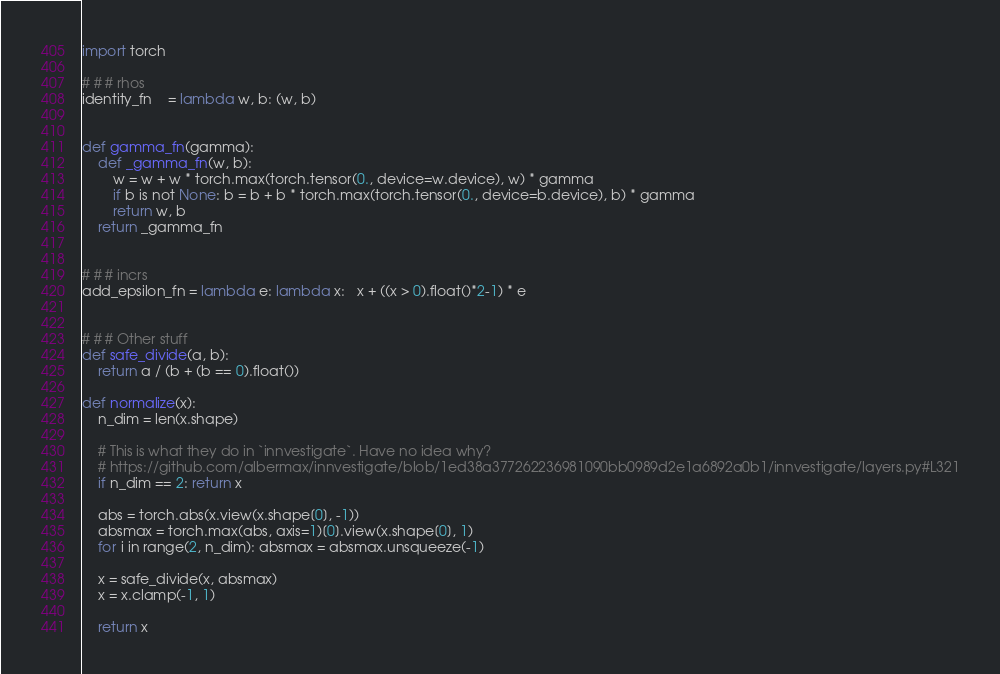<code> <loc_0><loc_0><loc_500><loc_500><_Python_>import torch

# # # rhos
identity_fn    = lambda w, b: (w, b)


def gamma_fn(gamma): 
    def _gamma_fn(w, b):
        w = w + w * torch.max(torch.tensor(0., device=w.device), w) * gamma
        if b is not None: b = b + b * torch.max(torch.tensor(0., device=b.device), b) * gamma
        return w, b
    return _gamma_fn


# # # incrs
add_epsilon_fn = lambda e: lambda x:   x + ((x > 0).float()*2-1) * e


# # # Other stuff
def safe_divide(a, b):
    return a / (b + (b == 0).float())

def normalize(x):
    n_dim = len(x.shape)

    # This is what they do in `innvestigate`. Have no idea why?
    # https://github.com/albermax/innvestigate/blob/1ed38a377262236981090bb0989d2e1a6892a0b1/innvestigate/layers.py#L321
    if n_dim == 2: return x
    
    abs = torch.abs(x.view(x.shape[0], -1))
    absmax = torch.max(abs, axis=1)[0].view(x.shape[0], 1)
    for i in range(2, n_dim): absmax = absmax.unsqueeze(-1)

    x = safe_divide(x, absmax)
    x = x.clamp(-1, 1)

    return x
</code> 